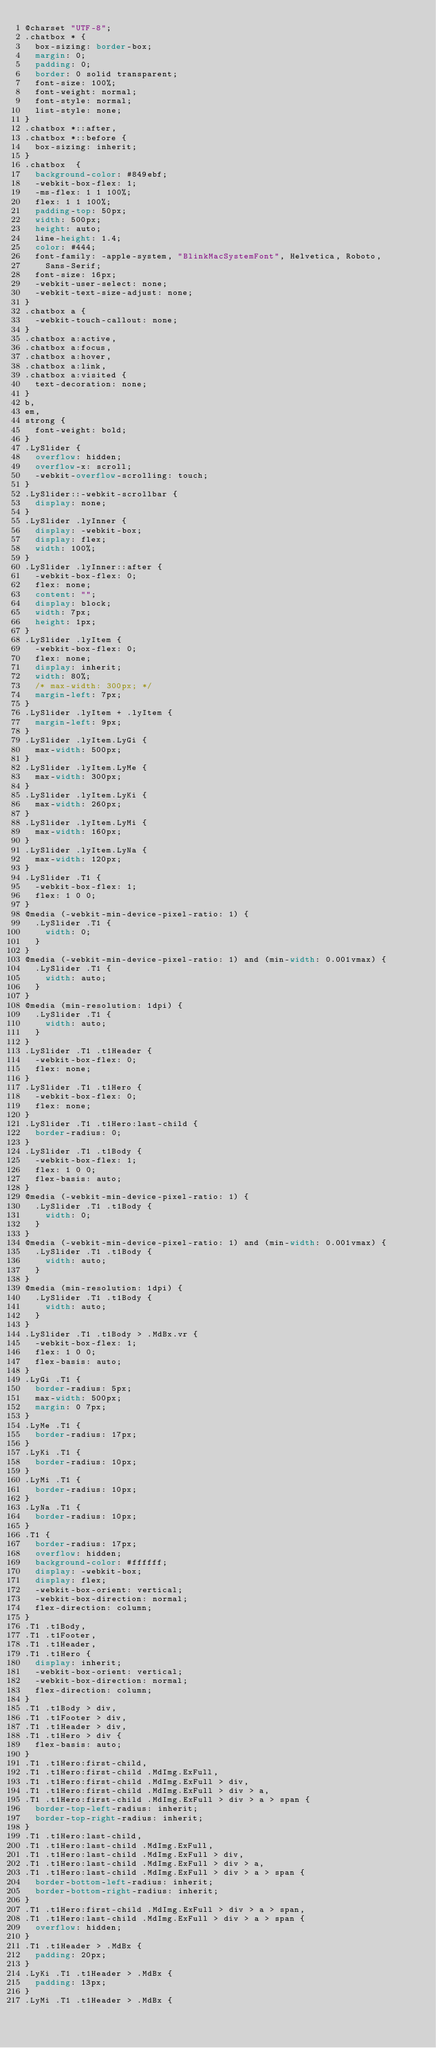Convert code to text. <code><loc_0><loc_0><loc_500><loc_500><_CSS_>@charset "UTF-8";
.chatbox * {
  box-sizing: border-box;
  margin: 0;
  padding: 0;
  border: 0 solid transparent;
  font-size: 100%;
  font-weight: normal;
  font-style: normal;
  list-style: none;
}
.chatbox *::after,
.chatbox *::before {
  box-sizing: inherit;
}
.chatbox  {
  background-color: #849ebf;
  -webkit-box-flex: 1;
  -ms-flex: 1 1 100%;
  flex: 1 1 100%;
  padding-top: 50px;
  width: 500px;
  height: auto;
  line-height: 1.4;
  color: #444;
  font-family: -apple-system, "BlinkMacSystemFont", Helvetica, Roboto,
    Sans-Serif;
  font-size: 16px;
  -webkit-user-select: none;
  -webkit-text-size-adjust: none;
}
.chatbox a {
  -webkit-touch-callout: none;
}
.chatbox a:active,
.chatbox a:focus,
.chatbox a:hover,
.chatbox a:link,
.chatbox a:visited {
  text-decoration: none;
}
b,
em,
strong {
  font-weight: bold;
}
.LySlider {
  overflow: hidden;
  overflow-x: scroll;
  -webkit-overflow-scrolling: touch;
}
.LySlider::-webkit-scrollbar {
  display: none;
}
.LySlider .lyInner {
  display: -webkit-box;
  display: flex;
  width: 100%;
}
.LySlider .lyInner::after {
  -webkit-box-flex: 0;
  flex: none;
  content: "";
  display: block;
  width: 7px;
  height: 1px;
}
.LySlider .lyItem {
  -webkit-box-flex: 0;
  flex: none;
  display: inherit;
  width: 80%;
  /* max-width: 300px; */
  margin-left: 7px;
}
.LySlider .lyItem + .lyItem {
  margin-left: 9px;
}
.LySlider .lyItem.LyGi {
  max-width: 500px;
}
.LySlider .lyItem.LyMe {
  max-width: 300px;
}
.LySlider .lyItem.LyKi {
  max-width: 260px;
}
.LySlider .lyItem.LyMi {
  max-width: 160px;
}
.LySlider .lyItem.LyNa {
  max-width: 120px;
}
.LySlider .T1 {
  -webkit-box-flex: 1;
  flex: 1 0 0;
}
@media (-webkit-min-device-pixel-ratio: 1) {
  .LySlider .T1 {
    width: 0;
  }
}
@media (-webkit-min-device-pixel-ratio: 1) and (min-width: 0.001vmax) {
  .LySlider .T1 {
    width: auto;
  }
}
@media (min-resolution: 1dpi) {
  .LySlider .T1 {
    width: auto;
  }
}
.LySlider .T1 .t1Header {
  -webkit-box-flex: 0;
  flex: none;
}
.LySlider .T1 .t1Hero {
  -webkit-box-flex: 0;
  flex: none;
}
.LySlider .T1 .t1Hero:last-child {
  border-radius: 0;
}
.LySlider .T1 .t1Body {
  -webkit-box-flex: 1;
  flex: 1 0 0;
  flex-basis: auto;
}
@media (-webkit-min-device-pixel-ratio: 1) {
  .LySlider .T1 .t1Body {
    width: 0;
  }
}
@media (-webkit-min-device-pixel-ratio: 1) and (min-width: 0.001vmax) {
  .LySlider .T1 .t1Body {
    width: auto;
  }
}
@media (min-resolution: 1dpi) {
  .LySlider .T1 .t1Body {
    width: auto;
  }
}
.LySlider .T1 .t1Body > .MdBx.vr {
  -webkit-box-flex: 1;
  flex: 1 0 0;
  flex-basis: auto;
}
.LyGi .T1 {
  border-radius: 5px;
  max-width: 500px;
  margin: 0 7px;
}
.LyMe .T1 {
  border-radius: 17px;
}
.LyKi .T1 {
  border-radius: 10px;
}
.LyMi .T1 {
  border-radius: 10px;
}
.LyNa .T1 {
  border-radius: 10px;
}
.T1 {
  border-radius: 17px;
  overflow: hidden;
  background-color: #ffffff;
  display: -webkit-box;
  display: flex;
  -webkit-box-orient: vertical;
  -webkit-box-direction: normal;
  flex-direction: column;
}
.T1 .t1Body,
.T1 .t1Footer,
.T1 .t1Header,
.T1 .t1Hero {
  display: inherit;
  -webkit-box-orient: vertical;
  -webkit-box-direction: normal;
  flex-direction: column;
}
.T1 .t1Body > div,
.T1 .t1Footer > div,
.T1 .t1Header > div,
.T1 .t1Hero > div {
  flex-basis: auto;
}
.T1 .t1Hero:first-child,
.T1 .t1Hero:first-child .MdImg.ExFull,
.T1 .t1Hero:first-child .MdImg.ExFull > div,
.T1 .t1Hero:first-child .MdImg.ExFull > div > a,
.T1 .t1Hero:first-child .MdImg.ExFull > div > a > span {
  border-top-left-radius: inherit;
  border-top-right-radius: inherit;
}
.T1 .t1Hero:last-child,
.T1 .t1Hero:last-child .MdImg.ExFull,
.T1 .t1Hero:last-child .MdImg.ExFull > div,
.T1 .t1Hero:last-child .MdImg.ExFull > div > a,
.T1 .t1Hero:last-child .MdImg.ExFull > div > a > span {
  border-bottom-left-radius: inherit;
  border-bottom-right-radius: inherit;
}
.T1 .t1Hero:first-child .MdImg.ExFull > div > a > span,
.T1 .t1Hero:last-child .MdImg.ExFull > div > a > span {
  overflow: hidden;
}
.T1 .t1Header > .MdBx {
  padding: 20px;
}
.LyKi .T1 .t1Header > .MdBx {
  padding: 13px;
}
.LyMi .T1 .t1Header > .MdBx {</code> 